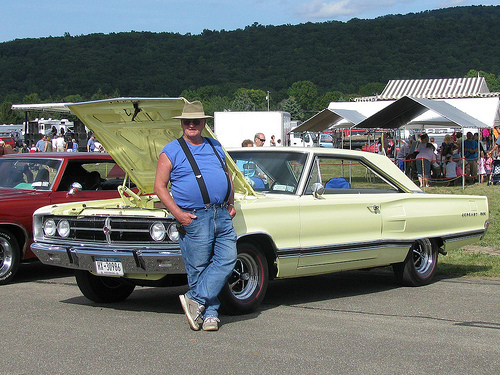<image>
Is there a car in front of the man? No. The car is not in front of the man. The spatial positioning shows a different relationship between these objects. 